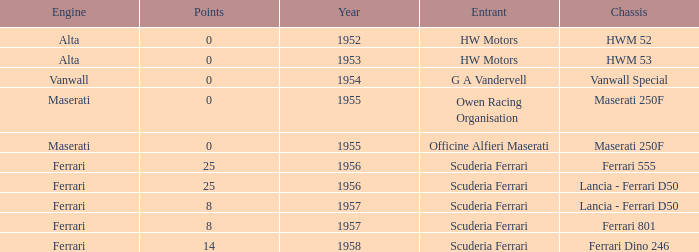Write the full table. {'header': ['Engine', 'Points', 'Year', 'Entrant', 'Chassis'], 'rows': [['Alta', '0', '1952', 'HW Motors', 'HWM 52'], ['Alta', '0', '1953', 'HW Motors', 'HWM 53'], ['Vanwall', '0', '1954', 'G A Vandervell', 'Vanwall Special'], ['Maserati', '0', '1955', 'Owen Racing Organisation', 'Maserati 250F'], ['Maserati', '0', '1955', 'Officine Alfieri Maserati', 'Maserati 250F'], ['Ferrari', '25', '1956', 'Scuderia Ferrari', 'Ferrari 555'], ['Ferrari', '25', '1956', 'Scuderia Ferrari', 'Lancia - Ferrari D50'], ['Ferrari', '8', '1957', 'Scuderia Ferrari', 'Lancia - Ferrari D50'], ['Ferrari', '8', '1957', 'Scuderia Ferrari', 'Ferrari 801'], ['Ferrari', '14', '1958', 'Scuderia Ferrari', 'Ferrari Dino 246']]} What is the entrant earlier than 1956 with a Vanwall Special chassis? G A Vandervell. 